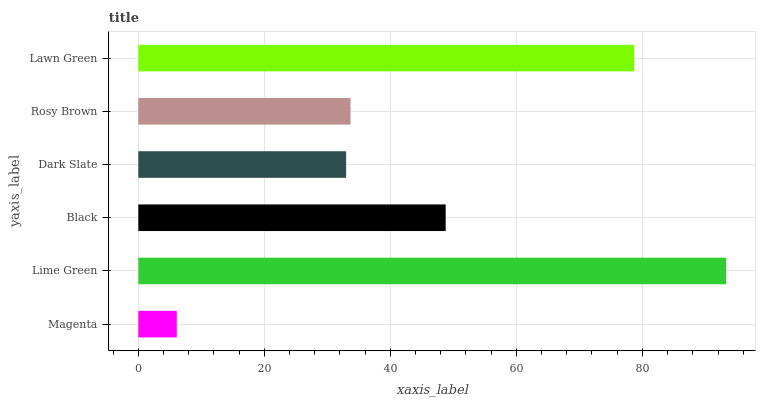Is Magenta the minimum?
Answer yes or no. Yes. Is Lime Green the maximum?
Answer yes or no. Yes. Is Black the minimum?
Answer yes or no. No. Is Black the maximum?
Answer yes or no. No. Is Lime Green greater than Black?
Answer yes or no. Yes. Is Black less than Lime Green?
Answer yes or no. Yes. Is Black greater than Lime Green?
Answer yes or no. No. Is Lime Green less than Black?
Answer yes or no. No. Is Black the high median?
Answer yes or no. Yes. Is Rosy Brown the low median?
Answer yes or no. Yes. Is Dark Slate the high median?
Answer yes or no. No. Is Magenta the low median?
Answer yes or no. No. 